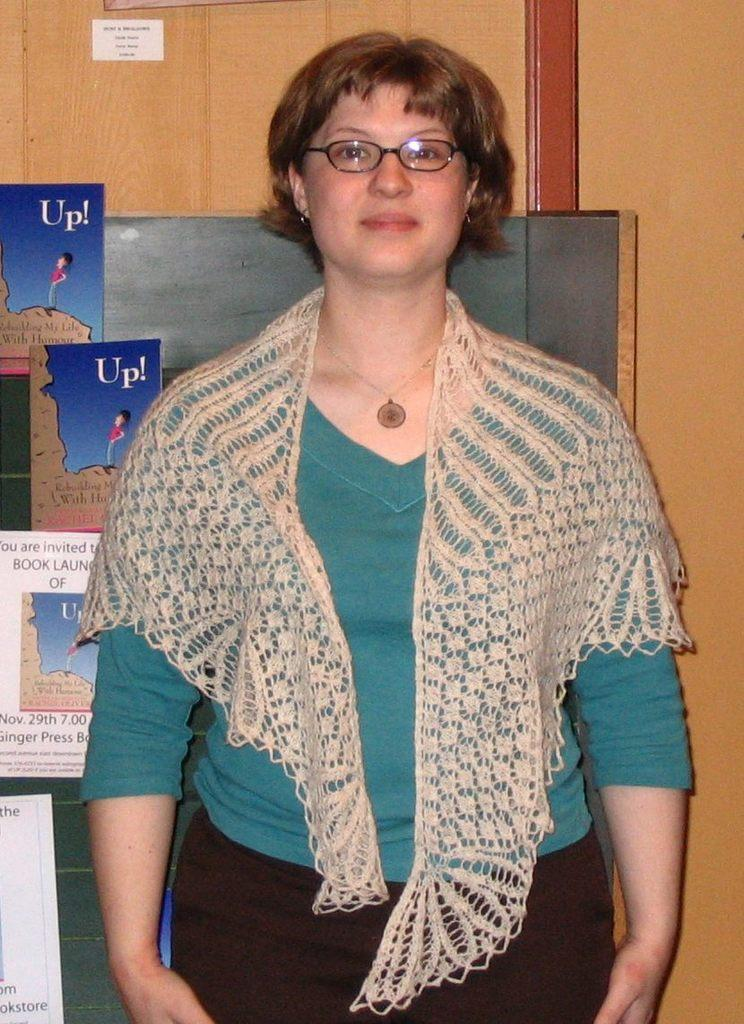Who is the main subject in the image? There is a woman standing in the image. Where is the woman located in the image? The woman is at the bottom of the image. What can be seen in the background of the image? There are books and a wall in the background of the image. What type of paper is the woman using to communicate with her sisters in the image? There is no paper or mention of sisters in the image. 